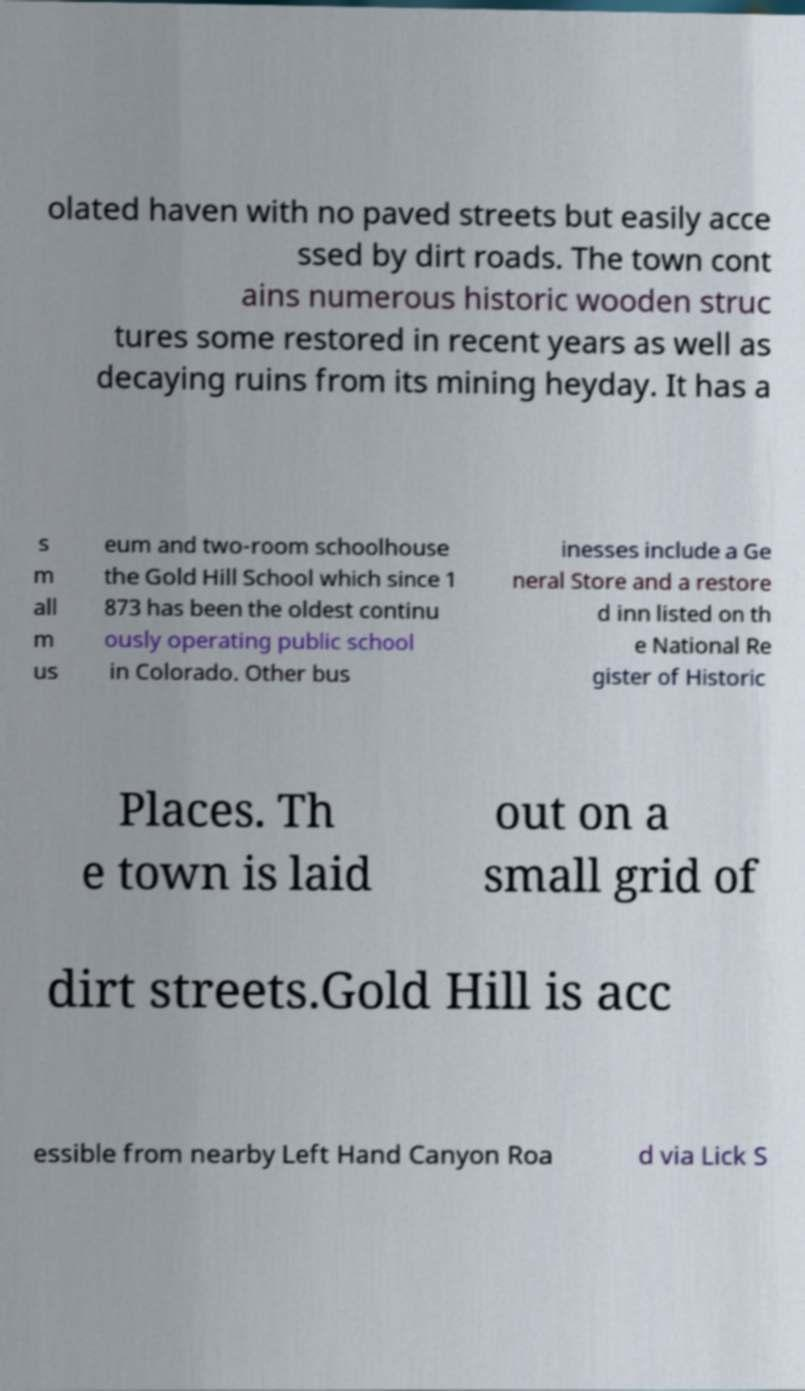Could you assist in decoding the text presented in this image and type it out clearly? olated haven with no paved streets but easily acce ssed by dirt roads. The town cont ains numerous historic wooden struc tures some restored in recent years as well as decaying ruins from its mining heyday. It has a s m all m us eum and two-room schoolhouse the Gold Hill School which since 1 873 has been the oldest continu ously operating public school in Colorado. Other bus inesses include a Ge neral Store and a restore d inn listed on th e National Re gister of Historic Places. Th e town is laid out on a small grid of dirt streets.Gold Hill is acc essible from nearby Left Hand Canyon Roa d via Lick S 